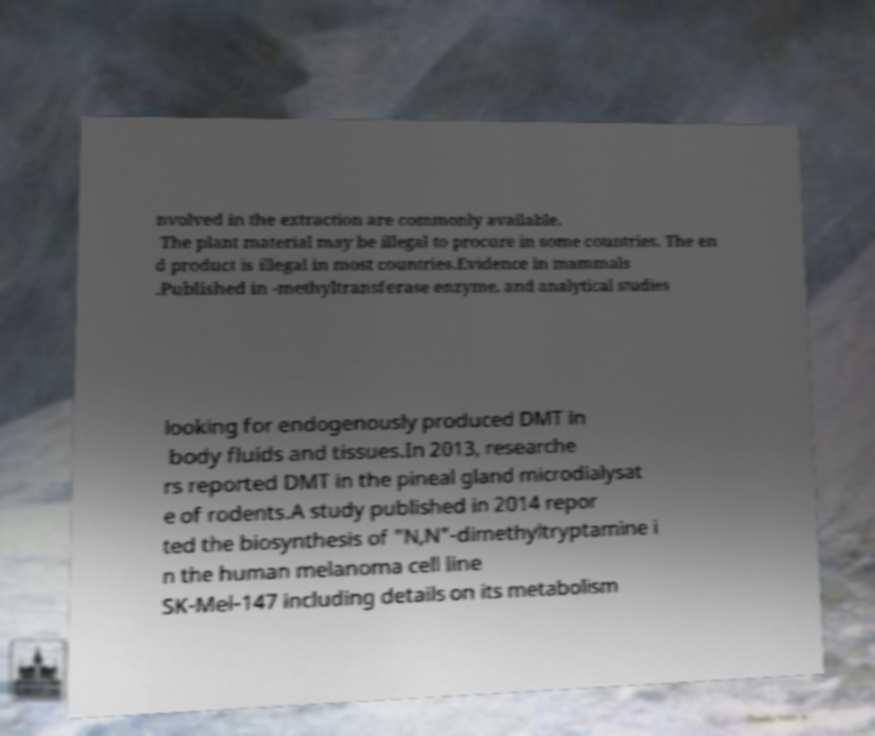There's text embedded in this image that I need extracted. Can you transcribe it verbatim? nvolved in the extraction are commonly available. The plant material may be illegal to procure in some countries. The en d product is illegal in most countries.Evidence in mammals .Published in -methyltransferase enzyme, and analytical studies looking for endogenously produced DMT in body fluids and tissues.In 2013, researche rs reported DMT in the pineal gland microdialysat e of rodents.A study published in 2014 repor ted the biosynthesis of "N,N"-dimethyltryptamine i n the human melanoma cell line SK-Mel-147 including details on its metabolism 